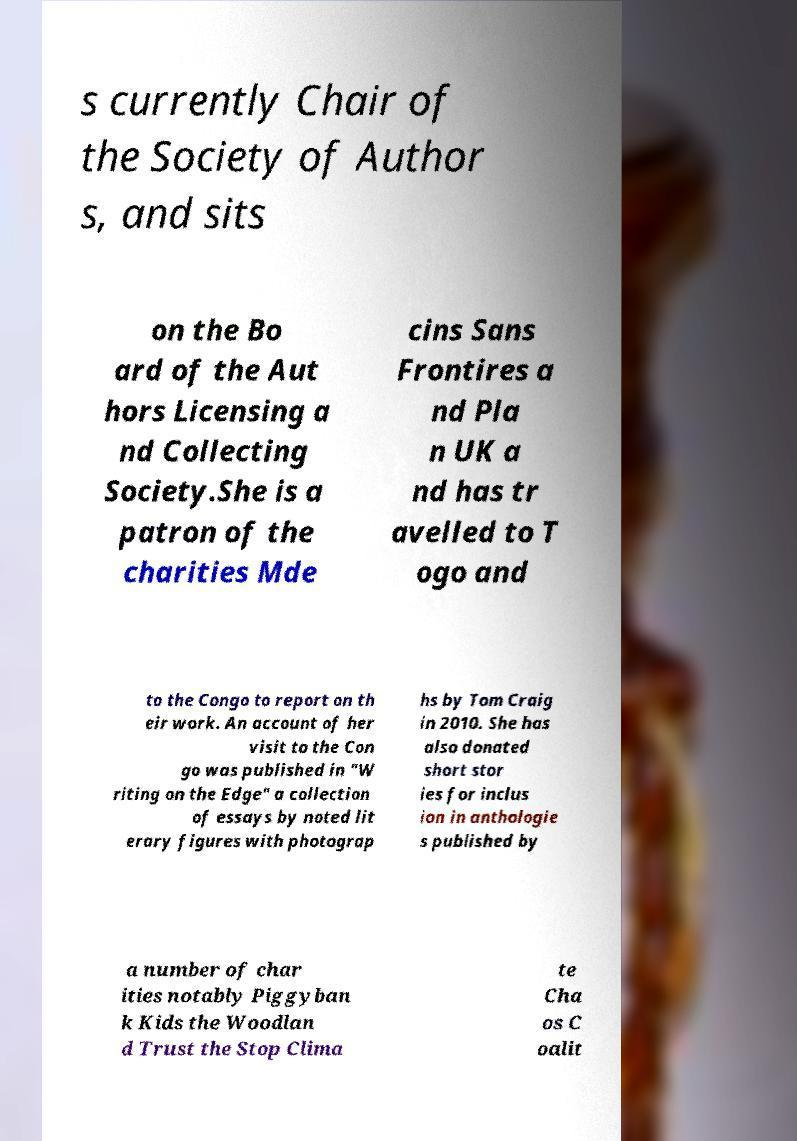Could you extract and type out the text from this image? s currently Chair of the Society of Author s, and sits on the Bo ard of the Aut hors Licensing a nd Collecting Society.She is a patron of the charities Mde cins Sans Frontires a nd Pla n UK a nd has tr avelled to T ogo and to the Congo to report on th eir work. An account of her visit to the Con go was published in "W riting on the Edge" a collection of essays by noted lit erary figures with photograp hs by Tom Craig in 2010. She has also donated short stor ies for inclus ion in anthologie s published by a number of char ities notably Piggyban k Kids the Woodlan d Trust the Stop Clima te Cha os C oalit 